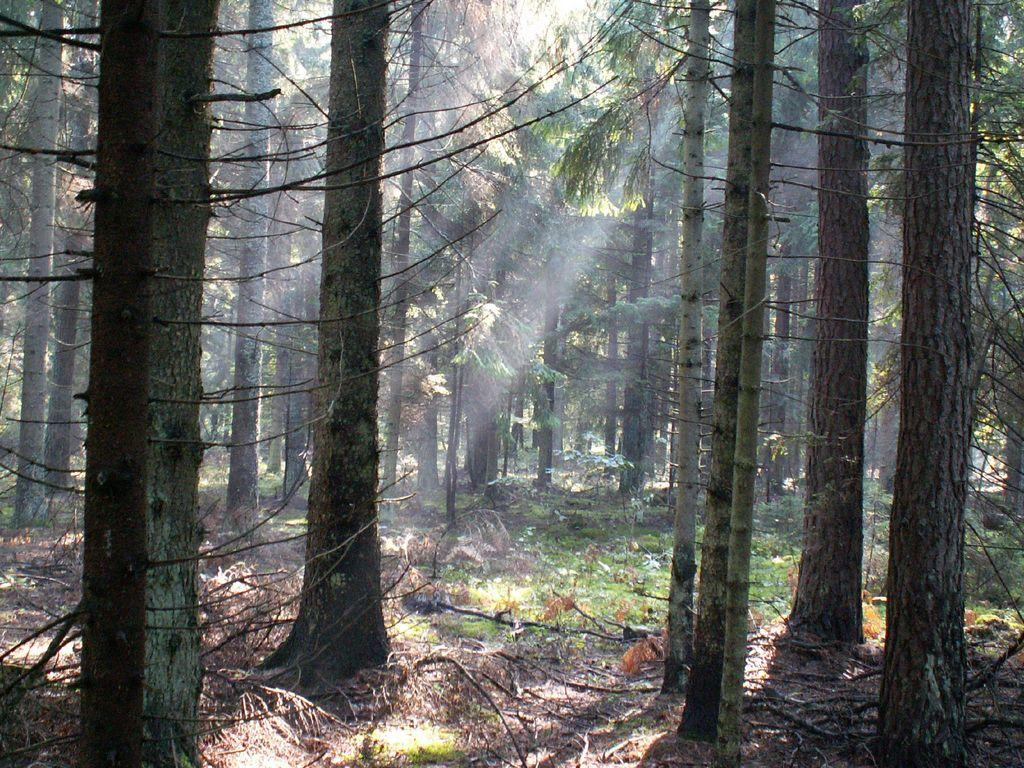What type of vegetation can be seen in the image? There are trees in the image. What objects are on the ground in the image? There are sticks and plants on the ground in the image. How many rabbits can be seen wearing masks in the image? There are no rabbits or masks present in the image. What finger is pointing at the trees in the image? There are no fingers visible in the image. 